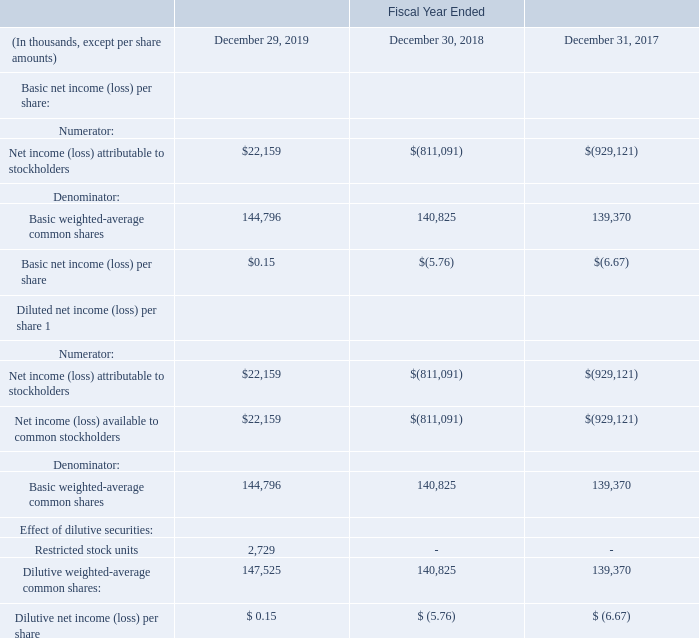Note 15. NET INCOME (LOSS) PER SHARE
We calculate basic net income (loss) per share by dividing earnings allocated to common stockholders by the basic weighted-average number of common shares outstanding for the period.
Diluted weighted-average shares is computed using basic weighted-average number of common shares outstanding plus any potentially dilutive securities outstanding during the period using the treasury-stock-type method and the if-converted method, except when their effect is anti-dilutive. Potentially dilutive securities include stock options, restricted stock units, and the outstanding senior convertible debentures.
The following table presents the calculation of basic and diluted net income (loss) per share attributable to stockholders:
1 As a result of our net loss attributable to stockholders for fiscal 2019, 2018, and 2017, the inclusion of all potentially dilutive stock options, restricted stock units, and common shares under noted warrants and convertible debt would be anti-dilutive. Therefore, those stock options, restricted stock units and shares were excluded from the computation of the weighted-average shares for diluted net loss per share for such periods.
How was the basic net income (loss) per share calculated? By dividing earnings allocated to common stockholders by the basic weighted-average number of common shares outstanding for the period. What does potentially dilutive securities consist of? Stock options, restricted stock units, and the outstanding senior convertible debentures. In which years was the calculation of basic and diluted net income (loss) per share attributable to stockholders recorded for? 2019, 2018, 2017. In which year is the dilutive net income  per share the highest? $ 0.15 > $ (5.76) > $ (6.67)
Answer: 2019. What is the change in dilutive weighted-average common shares from 2018 to 2019?
Answer scale should be: thousand. 147,525 - 140,825 
Answer: 6700. What is the percentage change in dilutive weighted-average common shares from 2017 to 2019?
Answer scale should be: percent. (147,525 - 139,370)/139,370 
Answer: 5.85. 